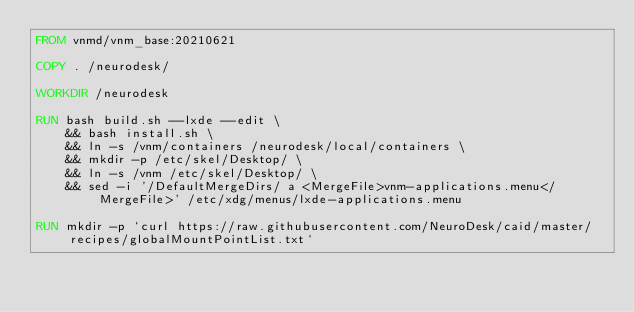<code> <loc_0><loc_0><loc_500><loc_500><_Dockerfile_>FROM vnmd/vnm_base:20210621

COPY . /neurodesk/

WORKDIR /neurodesk

RUN bash build.sh --lxde --edit \
    && bash install.sh \
    && ln -s /vnm/containers /neurodesk/local/containers \
    && mkdir -p /etc/skel/Desktop/ \
    && ln -s /vnm /etc/skel/Desktop/ \
    && sed -i '/DefaultMergeDirs/ a <MergeFile>vnm-applications.menu</MergeFile>' /etc/xdg/menus/lxde-applications.menu

RUN mkdir -p `curl https://raw.githubusercontent.com/NeuroDesk/caid/master/recipes/globalMountPointList.txt`</code> 